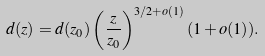Convert formula to latex. <formula><loc_0><loc_0><loc_500><loc_500>d ( z ) = d ( z _ { 0 } ) \left ( \frac { z } { z _ { 0 } } \right ) ^ { 3 / 2 + o ( 1 ) } ( 1 + o ( 1 ) ) .</formula> 